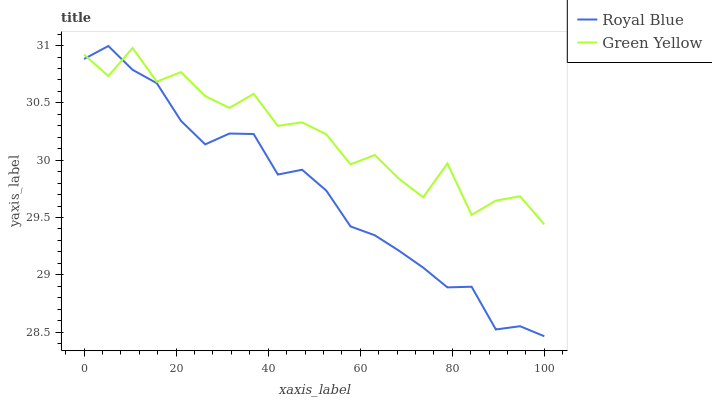Does Royal Blue have the minimum area under the curve?
Answer yes or no. Yes. Does Green Yellow have the maximum area under the curve?
Answer yes or no. Yes. Does Green Yellow have the minimum area under the curve?
Answer yes or no. No. Is Royal Blue the smoothest?
Answer yes or no. Yes. Is Green Yellow the roughest?
Answer yes or no. Yes. Is Green Yellow the smoothest?
Answer yes or no. No. Does Green Yellow have the lowest value?
Answer yes or no. No. Does Green Yellow have the highest value?
Answer yes or no. No. 